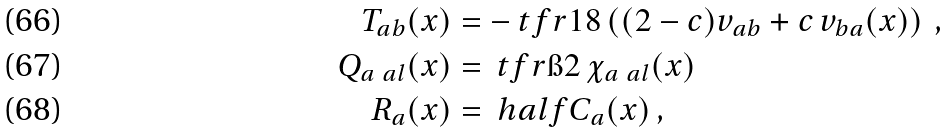Convert formula to latex. <formula><loc_0><loc_0><loc_500><loc_500>T _ { a b } ( x ) & = - \ t f r { 1 } { 8 } \left ( ( 2 - c ) v _ { a b } + c \, v _ { b a } ( x ) \right ) \, , \\ Q _ { a \ a l } ( x ) & = \ t f r { \i } { 2 } \, \chi _ { a \ a l } ( x ) \\ R _ { a } ( x ) & = \ h a l f C _ { a } ( x ) \, ,</formula> 